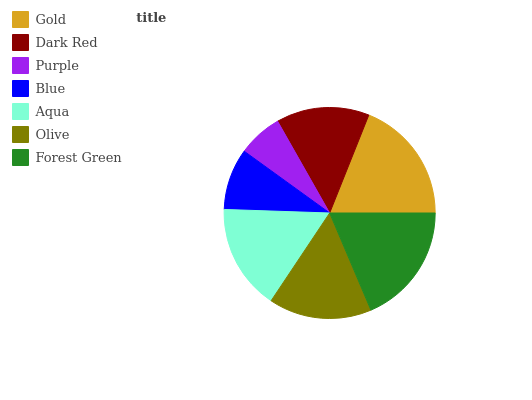Is Purple the minimum?
Answer yes or no. Yes. Is Gold the maximum?
Answer yes or no. Yes. Is Dark Red the minimum?
Answer yes or no. No. Is Dark Red the maximum?
Answer yes or no. No. Is Gold greater than Dark Red?
Answer yes or no. Yes. Is Dark Red less than Gold?
Answer yes or no. Yes. Is Dark Red greater than Gold?
Answer yes or no. No. Is Gold less than Dark Red?
Answer yes or no. No. Is Olive the high median?
Answer yes or no. Yes. Is Olive the low median?
Answer yes or no. Yes. Is Dark Red the high median?
Answer yes or no. No. Is Purple the low median?
Answer yes or no. No. 